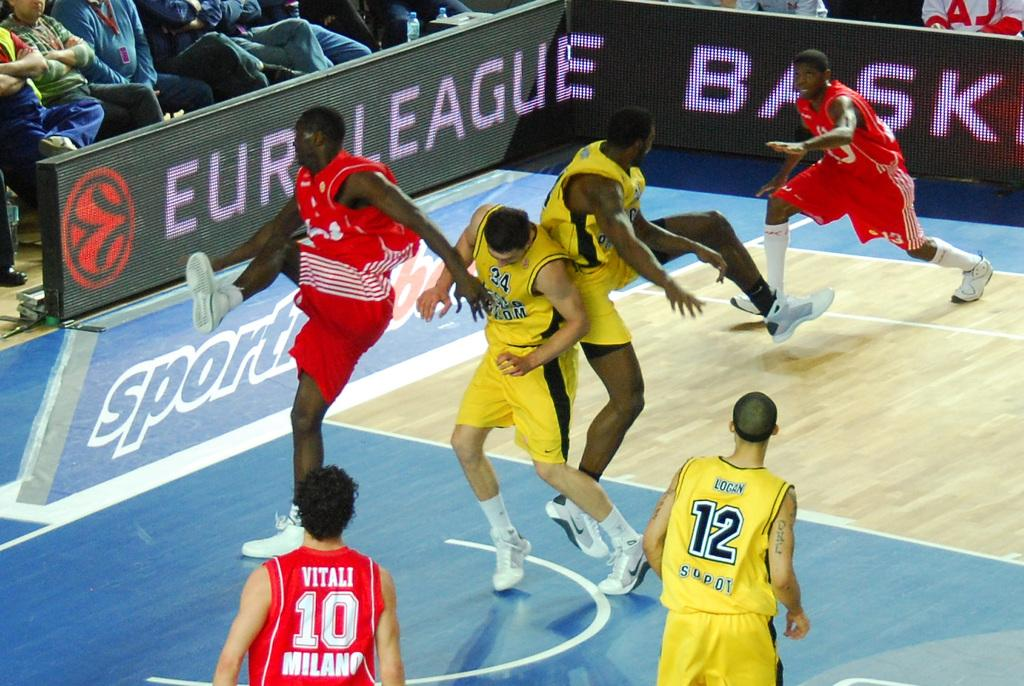Provide a one-sentence caption for the provided image. Two Euro League basketball teams on a court with one team dressed in red and another team in yellow as they are being looked at by a crowd. 